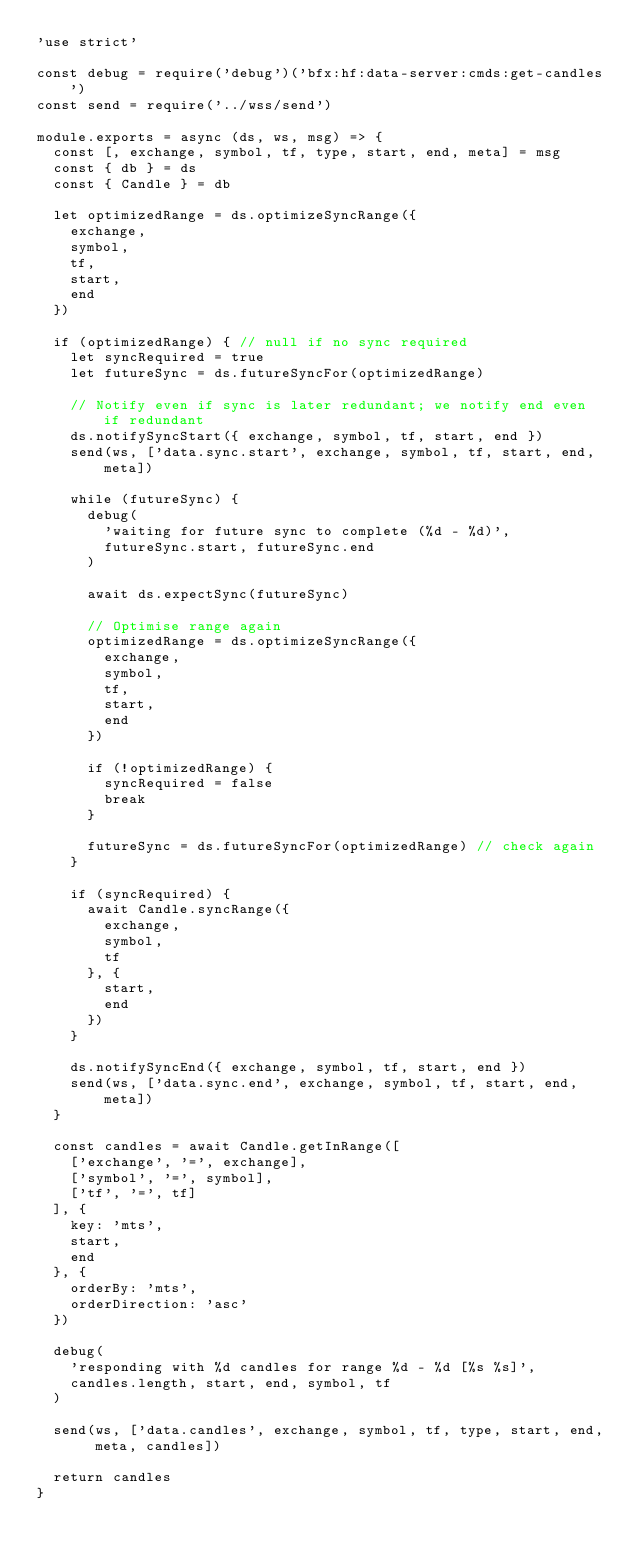<code> <loc_0><loc_0><loc_500><loc_500><_JavaScript_>'use strict'

const debug = require('debug')('bfx:hf:data-server:cmds:get-candles')
const send = require('../wss/send')

module.exports = async (ds, ws, msg) => {
  const [, exchange, symbol, tf, type, start, end, meta] = msg
  const { db } = ds
  const { Candle } = db

  let optimizedRange = ds.optimizeSyncRange({
    exchange,
    symbol,
    tf,
    start,
    end
  })

  if (optimizedRange) { // null if no sync required
    let syncRequired = true
    let futureSync = ds.futureSyncFor(optimizedRange)

    // Notify even if sync is later redundant; we notify end even if redundant
    ds.notifySyncStart({ exchange, symbol, tf, start, end })
    send(ws, ['data.sync.start', exchange, symbol, tf, start, end, meta])

    while (futureSync) {
      debug(
        'waiting for future sync to complete (%d - %d)',
        futureSync.start, futureSync.end
      )

      await ds.expectSync(futureSync)

      // Optimise range again
      optimizedRange = ds.optimizeSyncRange({
        exchange,
        symbol,
        tf,
        start,
        end
      })

      if (!optimizedRange) {
        syncRequired = false
        break
      }

      futureSync = ds.futureSyncFor(optimizedRange) // check again
    }

    if (syncRequired) {
      await Candle.syncRange({
        exchange,
        symbol,
        tf
      }, {
        start,
        end
      })
    }

    ds.notifySyncEnd({ exchange, symbol, tf, start, end })
    send(ws, ['data.sync.end', exchange, symbol, tf, start, end, meta])
  }

  const candles = await Candle.getInRange([
    ['exchange', '=', exchange],
    ['symbol', '=', symbol],
    ['tf', '=', tf]
  ], {
    key: 'mts',
    start,
    end
  }, {
    orderBy: 'mts',
    orderDirection: 'asc'
  })

  debug(
    'responding with %d candles for range %d - %d [%s %s]',
    candles.length, start, end, symbol, tf
  )

  send(ws, ['data.candles', exchange, symbol, tf, type, start, end, meta, candles])

  return candles
}
</code> 